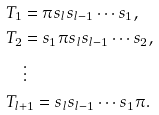Convert formula to latex. <formula><loc_0><loc_0><loc_500><loc_500>& T _ { 1 } = \pi s _ { l } s _ { l - 1 } \cdots s _ { 1 } , \\ & T _ { 2 } = s _ { 1 } \pi s _ { l } s _ { l - 1 } \cdots s _ { 2 } , \\ & \quad \vdots \\ & T _ { l + 1 } = s _ { l } s _ { l - 1 } \cdots s _ { 1 } \pi .</formula> 